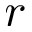<formula> <loc_0><loc_0><loc_500><loc_500>r</formula> 